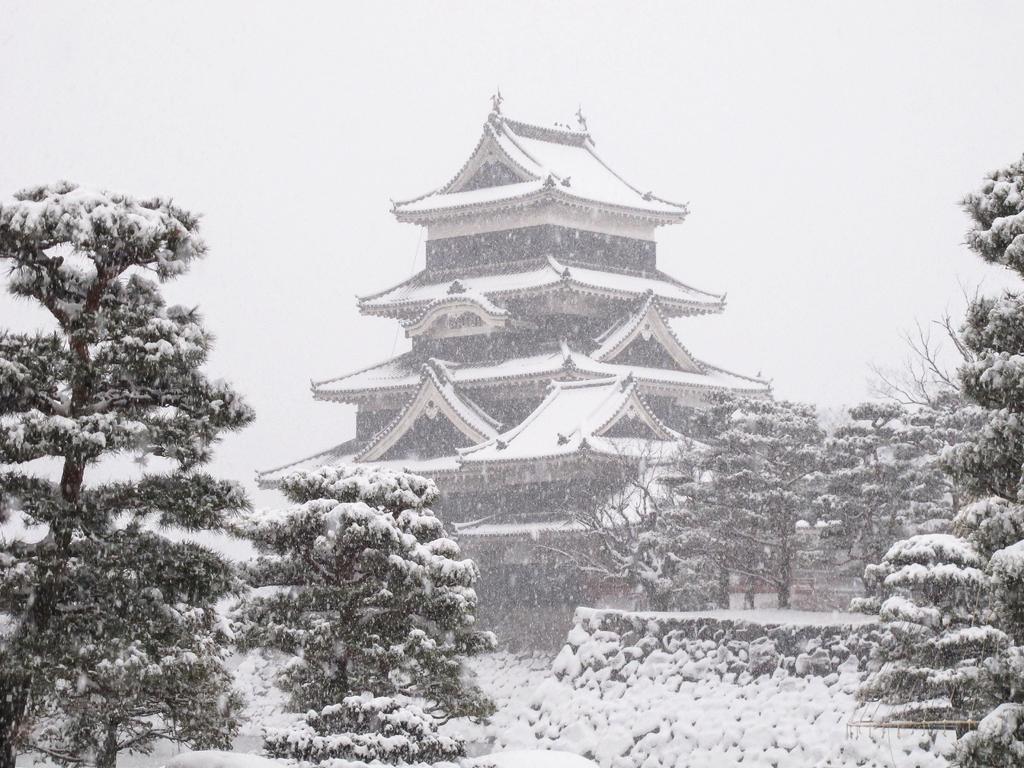How would you summarize this image in a sentence or two? It is a black and white picture. In the image in the center we can see trees,building,wall,roof and snow. In the background we can see the sky and clouds. 